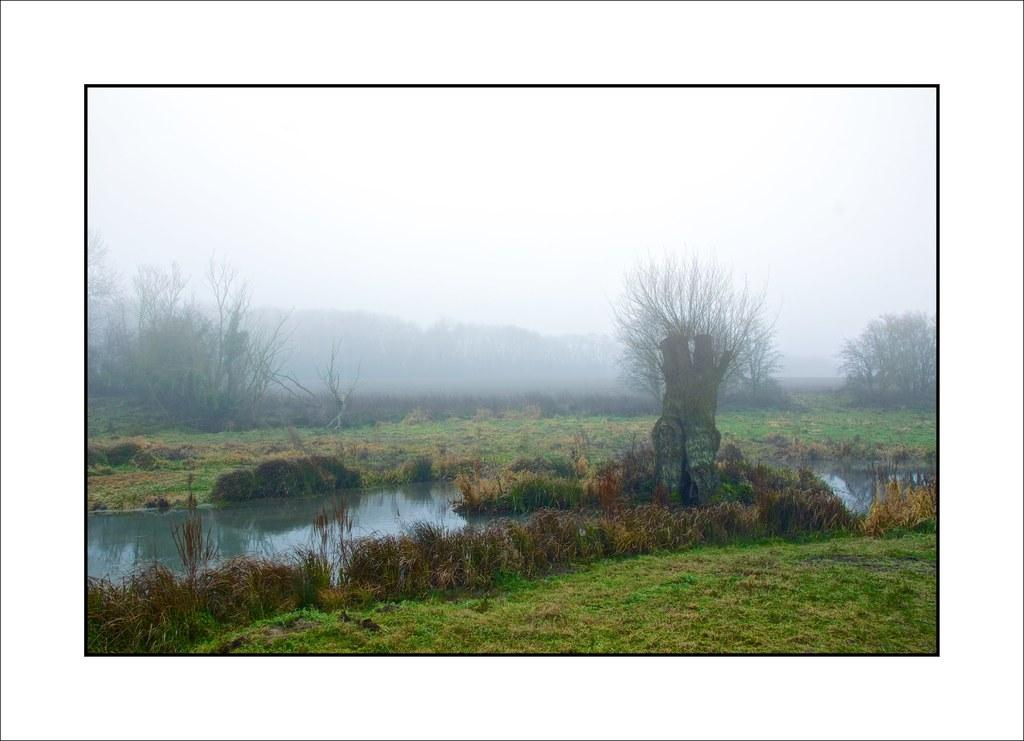What type of vegetation can be seen in the image? There is grass in the image. What else is present in the image besides grass? There is water and trees in the image. What can be seen in the background of the image? The sky is visible in the background of the image. How would you describe the sky in the image? The sky appears to be clear in the image. Where is the airport located in the image? There is no airport present in the image. What type of slip can be seen on the grass in the image? There is no slip present on the grass in the image. 